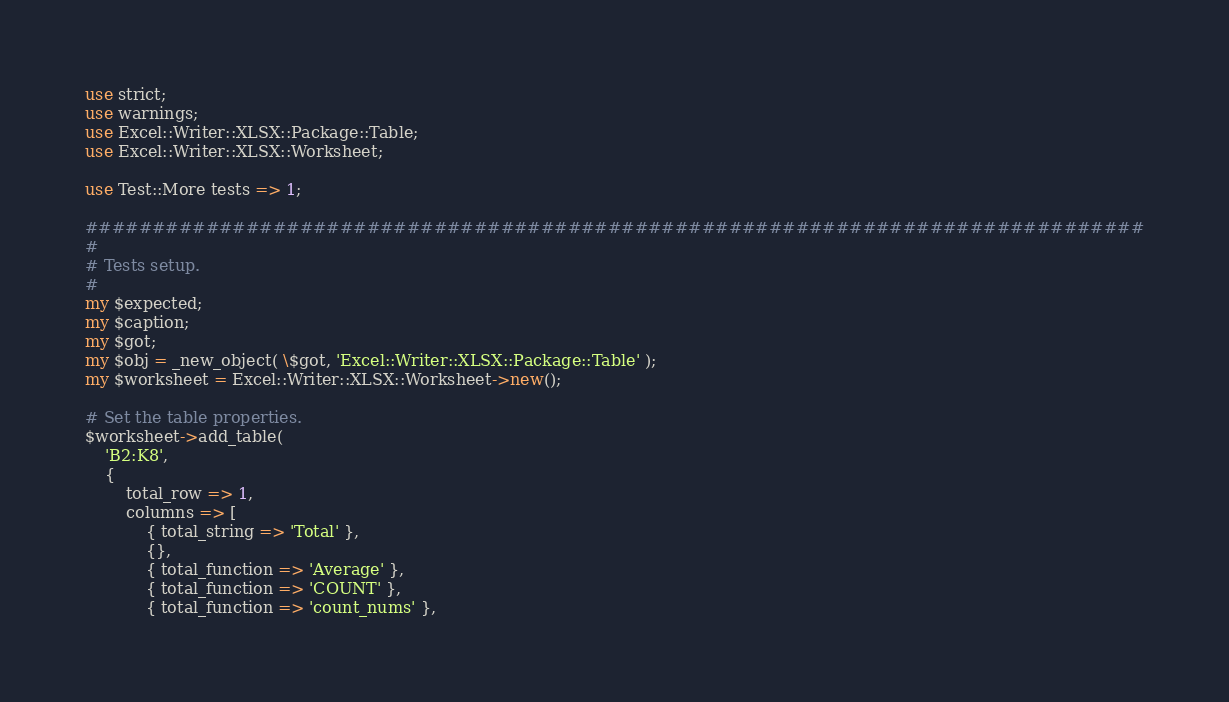<code> <loc_0><loc_0><loc_500><loc_500><_Perl_>use strict;
use warnings;
use Excel::Writer::XLSX::Package::Table;
use Excel::Writer::XLSX::Worksheet;

use Test::More tests => 1;

###############################################################################
#
# Tests setup.
#
my $expected;
my $caption;
my $got;
my $obj = _new_object( \$got, 'Excel::Writer::XLSX::Package::Table' );
my $worksheet = Excel::Writer::XLSX::Worksheet->new();

# Set the table properties.
$worksheet->add_table(
    'B2:K8',
    {
        total_row => 1,
        columns => [
            { total_string => 'Total' },
            {},
            { total_function => 'Average' },
            { total_function => 'COUNT' },
            { total_function => 'count_nums' },</code> 